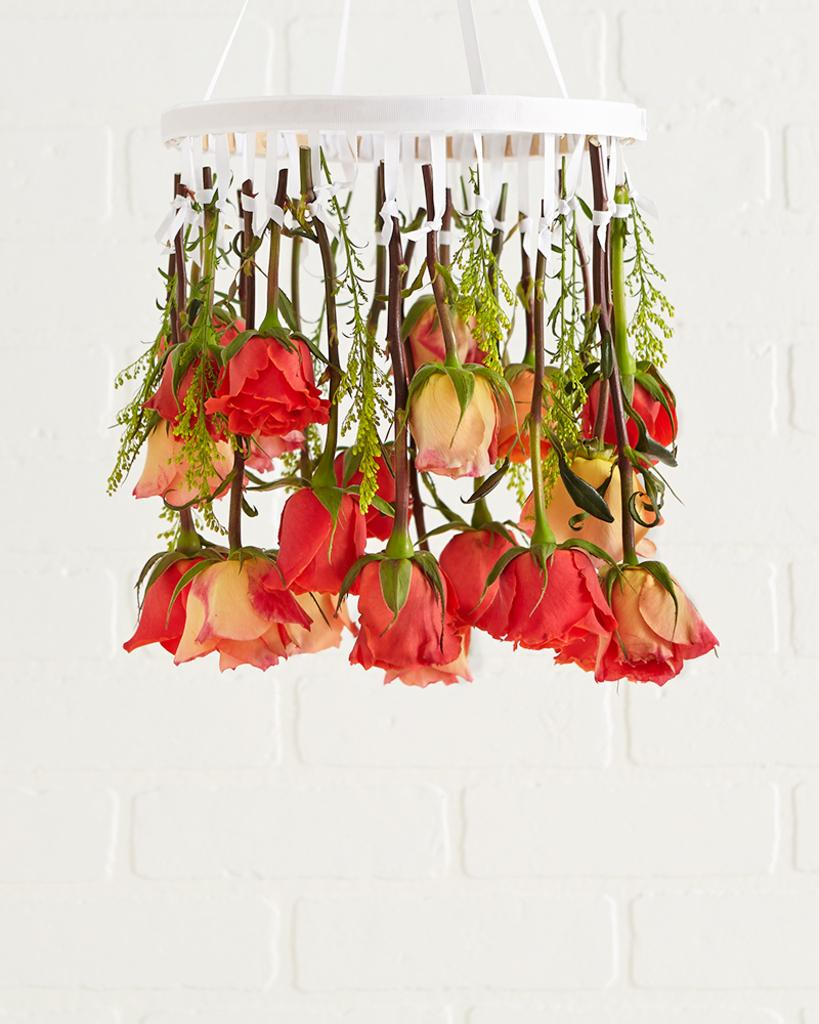What type of objects can be seen in the image? There are flowers in the image. How are the flowers arranged or displayed? The flowers are hanging from a white object. What colors are the flowers? The flowers are in red and cream colors. What is the color of the background in the image? The background of the image is white. Is there a wood structure visible in the image? There is no wood structure present in the image. What type of party is being held in the image? There is no party depicted in the image; it only features flowers hanging from a white object. 